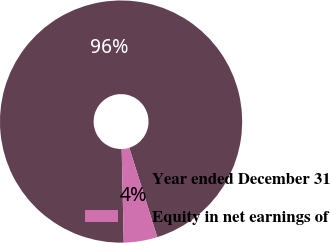Convert chart to OTSL. <chart><loc_0><loc_0><loc_500><loc_500><pie_chart><fcel>Year ended December 31<fcel>Equity in net earnings of<nl><fcel>95.52%<fcel>4.48%<nl></chart> 